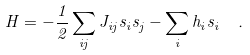<formula> <loc_0><loc_0><loc_500><loc_500>H = - \frac { 1 } { 2 } \sum _ { i j } J _ { i j } s _ { i } s _ { j } - \sum _ { i } h _ { i } s _ { i } \ .</formula> 